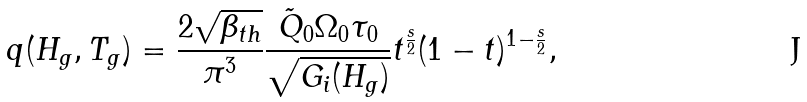<formula> <loc_0><loc_0><loc_500><loc_500>q ( H _ { g } , T _ { g } ) = \frac { 2 \sqrt { \beta _ { t h } } } { \pi ^ { 3 } } \frac { \tilde { Q } _ { 0 } \Omega _ { 0 } \tau _ { 0 } } { \sqrt { G _ { i } ( H _ { g } ) } } t ^ { \frac { s } { 2 } } ( 1 - t ) ^ { 1 - \frac { s } { 2 } } ,</formula> 